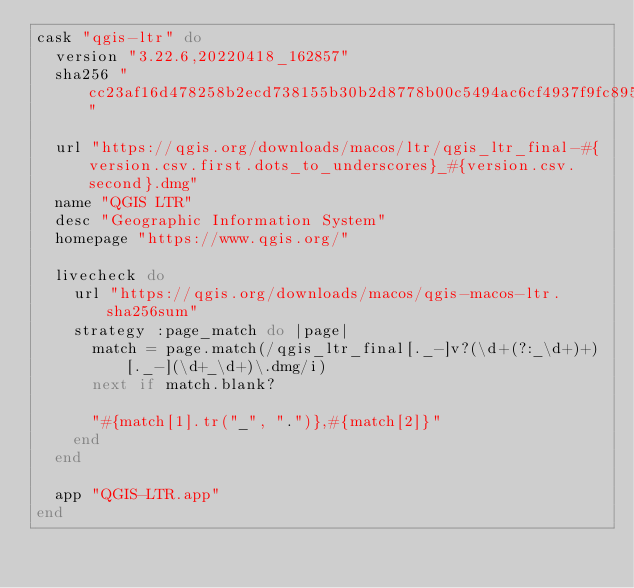<code> <loc_0><loc_0><loc_500><loc_500><_Ruby_>cask "qgis-ltr" do
  version "3.22.6,20220418_162857"
  sha256 "cc23af16d478258b2ecd738155b30b2d8778b00c5494ac6cf4937f9fc8955bcd"

  url "https://qgis.org/downloads/macos/ltr/qgis_ltr_final-#{version.csv.first.dots_to_underscores}_#{version.csv.second}.dmg"
  name "QGIS LTR"
  desc "Geographic Information System"
  homepage "https://www.qgis.org/"

  livecheck do
    url "https://qgis.org/downloads/macos/qgis-macos-ltr.sha256sum"
    strategy :page_match do |page|
      match = page.match(/qgis_ltr_final[._-]v?(\d+(?:_\d+)+)[._-](\d+_\d+)\.dmg/i)
      next if match.blank?

      "#{match[1].tr("_", ".")},#{match[2]}"
    end
  end

  app "QGIS-LTR.app"
end
</code> 